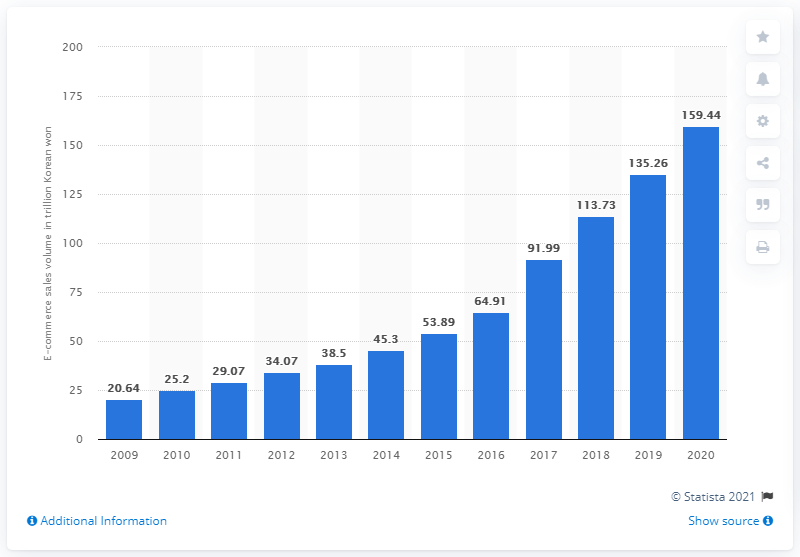Point out several critical features in this image. In 2020, the value of e-commerce sales in South Korea was 159.44. In 2020, e-commerce sales in South Korea surpassed 159 trillion South Korean won, indicating a significant growth in online shopping. 